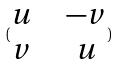<formula> <loc_0><loc_0><loc_500><loc_500>( \begin{matrix} u & & - v \\ v & & u \end{matrix} )</formula> 